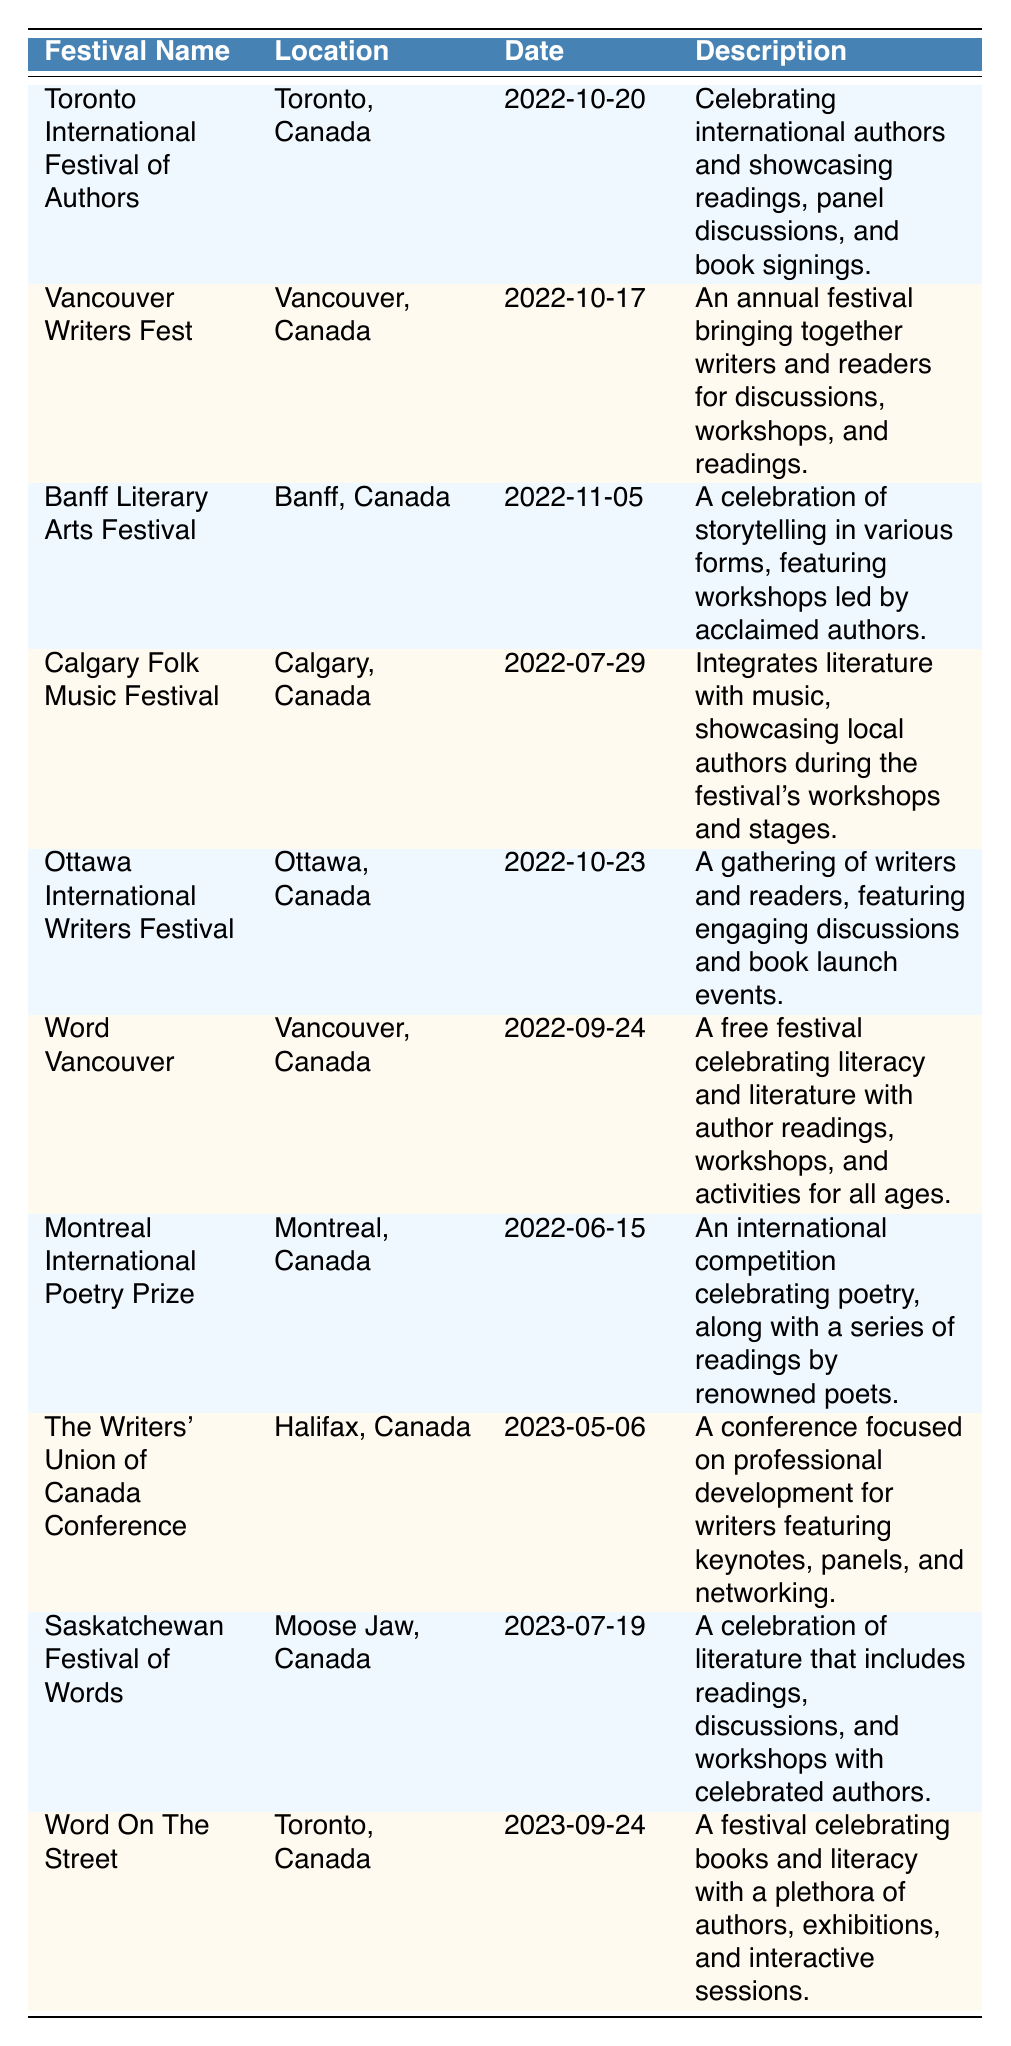What is the location of the Ottawa International Writers Festival? The table lists the location of each festival. For the Ottawa International Writers Festival, it specifically states that the location is "Ottawa, Canada."
Answer: Ottawa, Canada Which festival occurs on the latest date? By examining the date column, the festival with the latest date is "Word On The Street," which takes place on "2023-09-24."
Answer: Word On The Street How many festivals were held in 2022? The table shows festivals with their corresponding dates. Counting the entries for the year 2022, there are a total of 7 festivals listed.
Answer: 7 Is there a festival focused on poetry? The "Montreal International Poetry Prize" is specifically described in the table as an international competition celebrating poetry. Thus, the answer to the question is yes.
Answer: Yes What is the average date difference between the festivals held in 2023? The festivals in 2023 are "The Writers' Union of Canada Conference" (2023-05-06), "Saskatchewan Festival of Words" (2023-07-19), and "Word On The Street" (2023-09-24). The differences in days are 74 days (from May 6 to July 19) and 67 days (from July 19 to September 24). Calculating the average difference: (74 + 67) / 2 = 70.5 days.
Answer: 70.5 days List all festivals that took place in Vancouver. In the table, there are two entries for festivals located in Vancouver: "Vancouver Writers Fest" and "Word Vancouver." By checking the location column, both festivals are confirmed to be in Vancouver, Canada.
Answer: Vancouver Writers Fest, Word Vancouver 